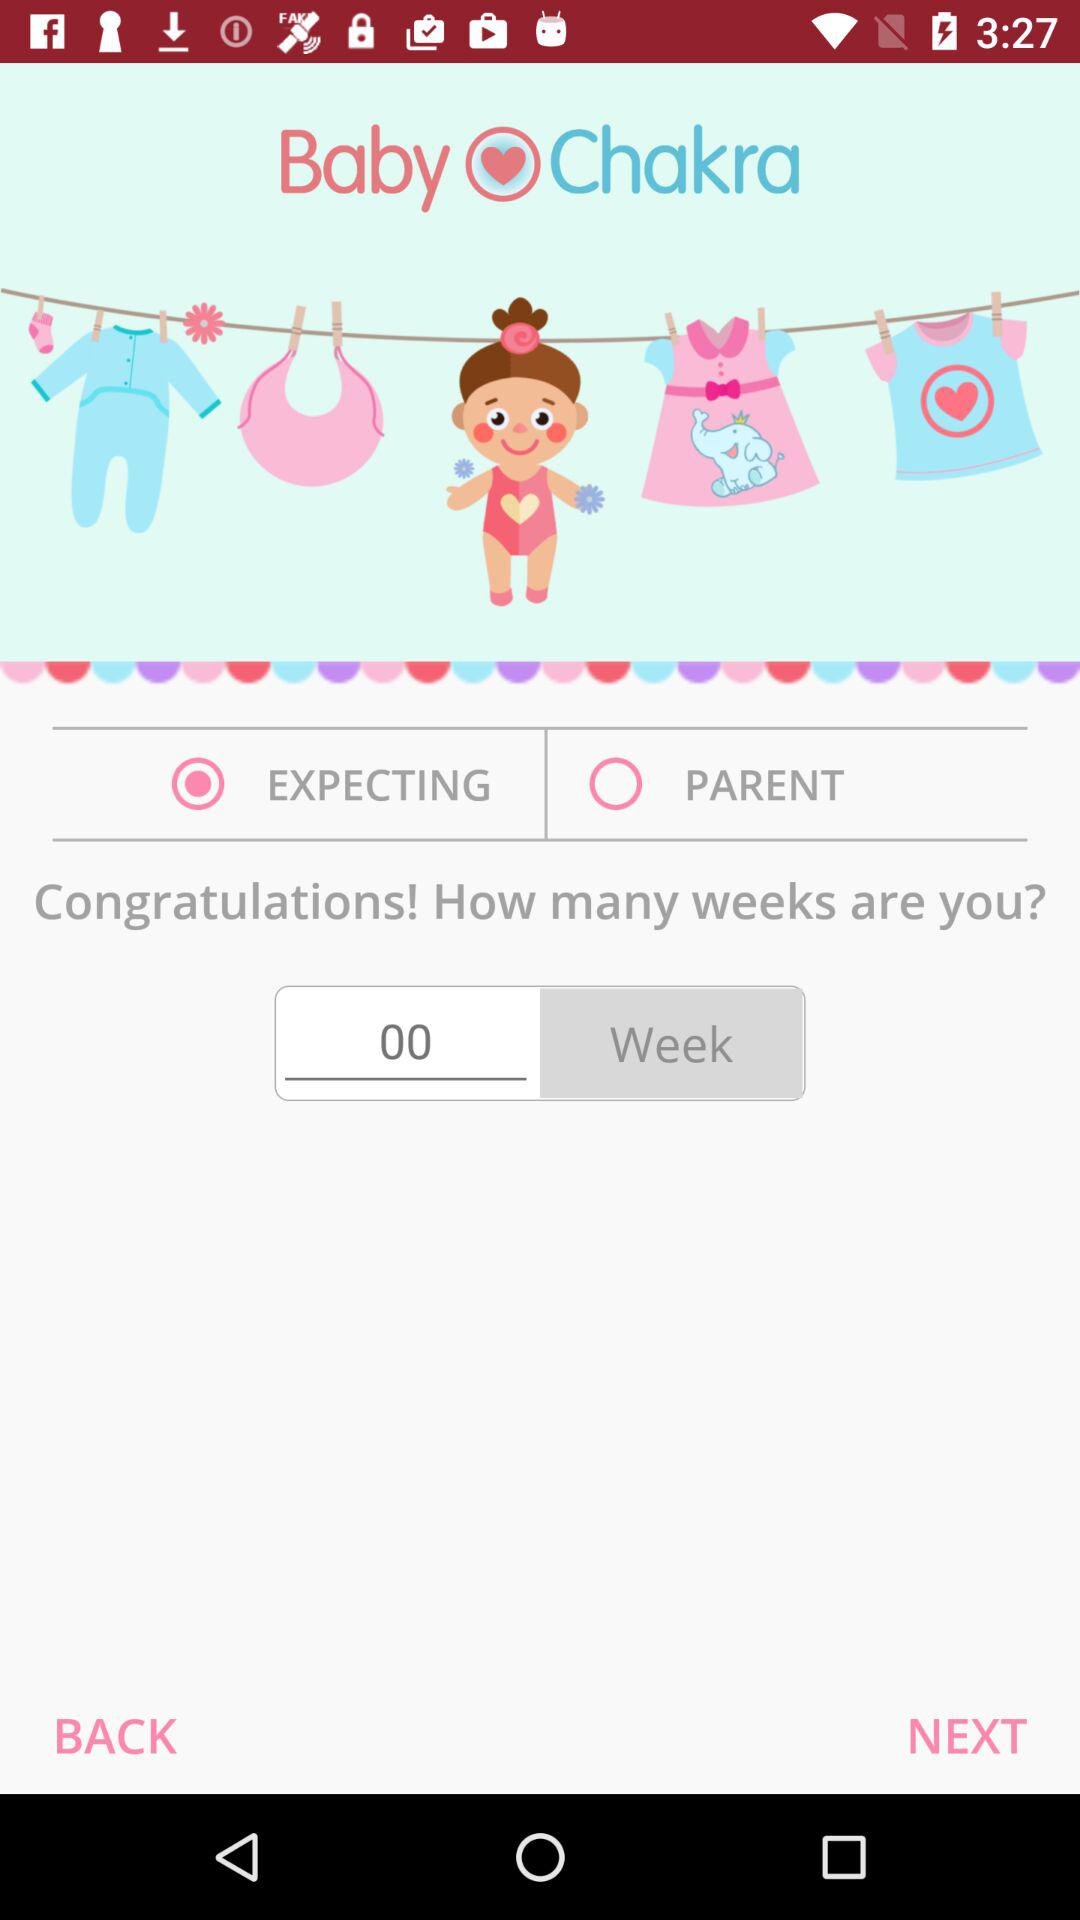How many weeks are mentioned? The week mentioned is 0. 